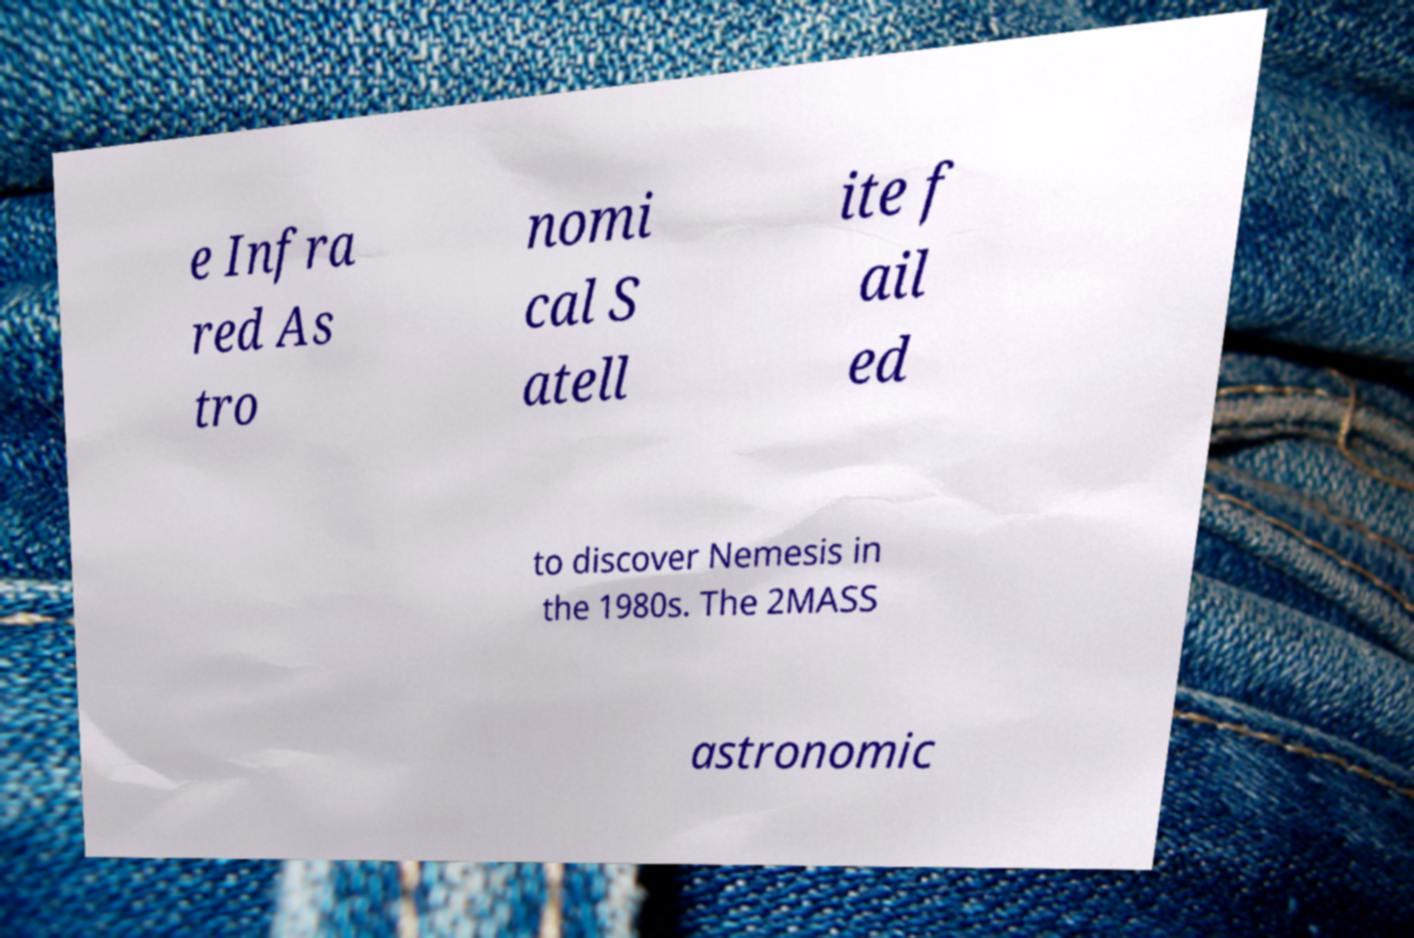Please identify and transcribe the text found in this image. e Infra red As tro nomi cal S atell ite f ail ed to discover Nemesis in the 1980s. The 2MASS astronomic 